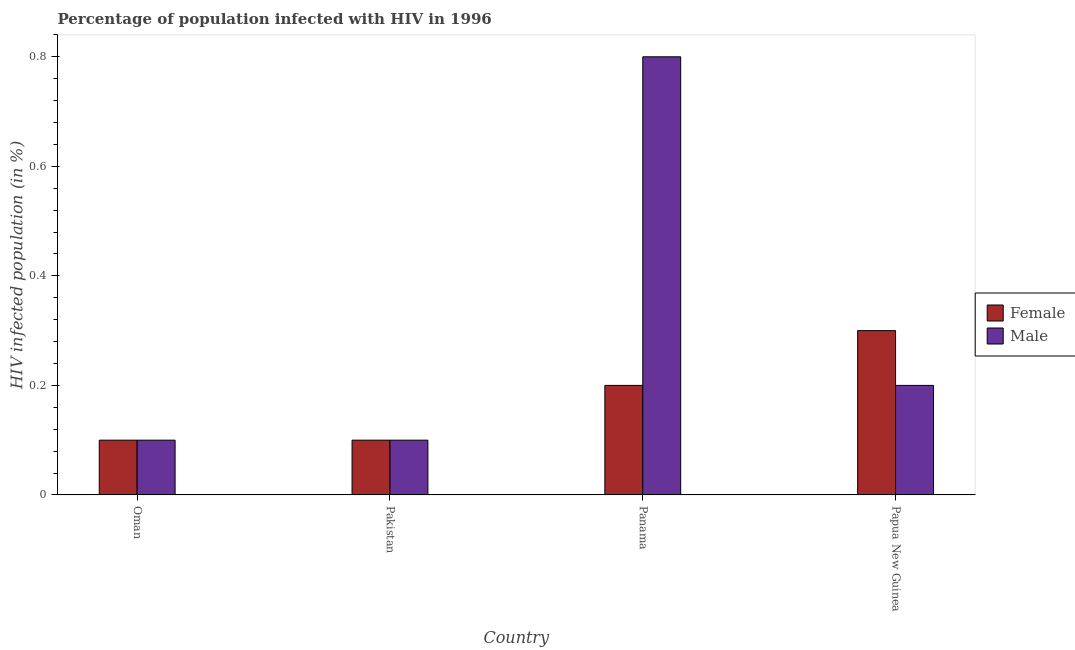How many different coloured bars are there?
Your answer should be compact. 2. Are the number of bars per tick equal to the number of legend labels?
Provide a succinct answer. Yes. How many bars are there on the 4th tick from the left?
Your response must be concise. 2. How many bars are there on the 4th tick from the right?
Your response must be concise. 2. What is the label of the 4th group of bars from the left?
Offer a very short reply. Papua New Guinea. In how many cases, is the number of bars for a given country not equal to the number of legend labels?
Offer a very short reply. 0. What is the percentage of males who are infected with hiv in Papua New Guinea?
Provide a succinct answer. 0.2. Across all countries, what is the maximum percentage of females who are infected with hiv?
Provide a short and direct response. 0.3. In which country was the percentage of males who are infected with hiv maximum?
Keep it short and to the point. Panama. In which country was the percentage of females who are infected with hiv minimum?
Your response must be concise. Oman. What is the total percentage of females who are infected with hiv in the graph?
Offer a terse response. 0.7. What is the difference between the percentage of males who are infected with hiv in Panama and the percentage of females who are infected with hiv in Papua New Guinea?
Your answer should be very brief. 0.5. What is the average percentage of males who are infected with hiv per country?
Offer a terse response. 0.3. What is the difference between the percentage of males who are infected with hiv and percentage of females who are infected with hiv in Panama?
Your answer should be very brief. 0.6. In how many countries, is the percentage of males who are infected with hiv greater than 0.24000000000000002 %?
Keep it short and to the point. 1. What is the ratio of the percentage of females who are infected with hiv in Oman to that in Papua New Guinea?
Provide a succinct answer. 0.33. Is the percentage of males who are infected with hiv in Pakistan less than that in Panama?
Make the answer very short. Yes. What is the difference between the highest and the second highest percentage of males who are infected with hiv?
Your answer should be compact. 0.6. What is the difference between the highest and the lowest percentage of females who are infected with hiv?
Keep it short and to the point. 0.2. In how many countries, is the percentage of females who are infected with hiv greater than the average percentage of females who are infected with hiv taken over all countries?
Offer a terse response. 2. Is the sum of the percentage of females who are infected with hiv in Pakistan and Papua New Guinea greater than the maximum percentage of males who are infected with hiv across all countries?
Provide a short and direct response. No. What does the 1st bar from the right in Panama represents?
Keep it short and to the point. Male. How many bars are there?
Your answer should be very brief. 8. Does the graph contain any zero values?
Keep it short and to the point. No. How many legend labels are there?
Provide a succinct answer. 2. What is the title of the graph?
Your answer should be compact. Percentage of population infected with HIV in 1996. Does "Automatic Teller Machines" appear as one of the legend labels in the graph?
Make the answer very short. No. What is the label or title of the X-axis?
Offer a terse response. Country. What is the label or title of the Y-axis?
Offer a terse response. HIV infected population (in %). What is the HIV infected population (in %) in Female in Oman?
Offer a very short reply. 0.1. What is the HIV infected population (in %) of Male in Oman?
Keep it short and to the point. 0.1. What is the HIV infected population (in %) of Male in Pakistan?
Offer a very short reply. 0.1. What is the HIV infected population (in %) in Female in Panama?
Make the answer very short. 0.2. What is the HIV infected population (in %) of Male in Papua New Guinea?
Ensure brevity in your answer.  0.2. Across all countries, what is the maximum HIV infected population (in %) in Male?
Make the answer very short. 0.8. What is the total HIV infected population (in %) in Male in the graph?
Ensure brevity in your answer.  1.2. What is the difference between the HIV infected population (in %) of Female in Oman and that in Panama?
Your answer should be very brief. -0.1. What is the difference between the HIV infected population (in %) in Female in Oman and that in Papua New Guinea?
Your response must be concise. -0.2. What is the difference between the HIV infected population (in %) of Male in Pakistan and that in Panama?
Offer a very short reply. -0.7. What is the difference between the HIV infected population (in %) of Female in Panama and that in Papua New Guinea?
Your answer should be very brief. -0.1. What is the difference between the HIV infected population (in %) in Male in Panama and that in Papua New Guinea?
Ensure brevity in your answer.  0.6. What is the difference between the HIV infected population (in %) of Female in Oman and the HIV infected population (in %) of Male in Panama?
Provide a succinct answer. -0.7. What is the difference between the HIV infected population (in %) of Female in Oman and the HIV infected population (in %) of Male in Papua New Guinea?
Keep it short and to the point. -0.1. What is the difference between the HIV infected population (in %) in Female in Pakistan and the HIV infected population (in %) in Male in Papua New Guinea?
Your answer should be compact. -0.1. What is the difference between the HIV infected population (in %) in Female in Panama and the HIV infected population (in %) in Male in Papua New Guinea?
Keep it short and to the point. 0. What is the average HIV infected population (in %) of Female per country?
Your answer should be compact. 0.17. What is the average HIV infected population (in %) of Male per country?
Your answer should be compact. 0.3. What is the difference between the HIV infected population (in %) of Female and HIV infected population (in %) of Male in Oman?
Your answer should be compact. 0. What is the difference between the HIV infected population (in %) in Female and HIV infected population (in %) in Male in Panama?
Keep it short and to the point. -0.6. What is the ratio of the HIV infected population (in %) of Female in Oman to that in Panama?
Provide a short and direct response. 0.5. What is the ratio of the HIV infected population (in %) in Female in Oman to that in Papua New Guinea?
Ensure brevity in your answer.  0.33. What is the ratio of the HIV infected population (in %) in Male in Oman to that in Papua New Guinea?
Your answer should be very brief. 0.5. What is the ratio of the HIV infected population (in %) of Female in Pakistan to that in Panama?
Offer a terse response. 0.5. What is the ratio of the HIV infected population (in %) of Female in Pakistan to that in Papua New Guinea?
Offer a very short reply. 0.33. What is the ratio of the HIV infected population (in %) of Male in Pakistan to that in Papua New Guinea?
Provide a succinct answer. 0.5. What is the ratio of the HIV infected population (in %) of Female in Panama to that in Papua New Guinea?
Provide a short and direct response. 0.67. 